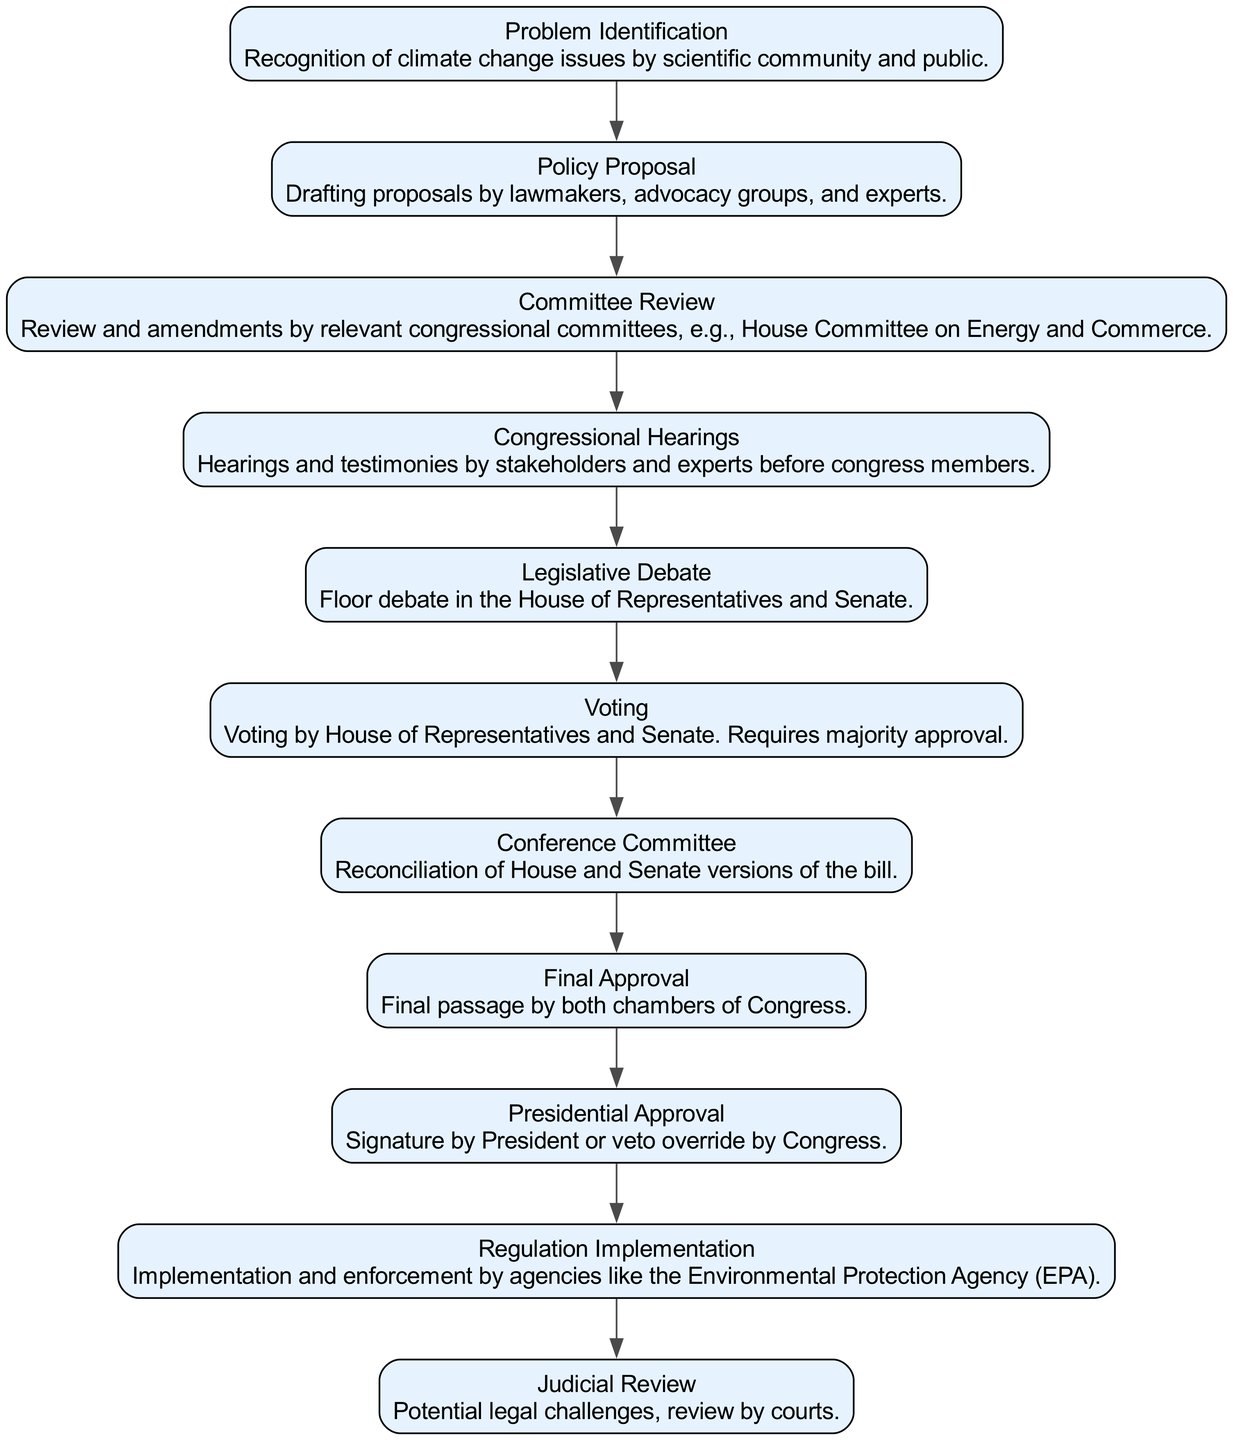What is the first step in the legislative process for enacting climate change regulations? The first step identified in the diagram is "Problem Identification," which is where the recognition of climate change issues occurs.
Answer: Problem Identification How many components are there in total? By counting the nodes in the diagram, there are 11 components listed.
Answer: 11 What happens after the "Policy Proposal"? The next step after "Policy Proposal" is "Committee Review," where the proposals are reviewed and amended by relevant congressional committees.
Answer: Committee Review Which component follows "Voting"? The component that follows "Voting" is "Conference Committee," which involves reconciling the House and Senate versions of the bill.
Answer: Conference Committee What role does the President play in the process? The President's role is encapsulated in the "Presidential Approval" step, where they either sign the bill or Congress may override a veto.
Answer: Presidential Approval How are legal challenges addressed in the process? Legal challenges are addressed during the "Judicial Review" phase, where potential challenges are reviewed by the courts.
Answer: Judicial Review What is the purpose of "Congressional Hearings"? The purpose of "Congressional Hearings" is to gather testimonies from stakeholders and experts before congress members.
Answer: Gather testimonies Describe the flow of the legislative process starting from "Legislative Debate" to "Regulation Implementation." After "Legislative Debate," the flow goes to "Voting" where the bill is voted upon. If approved, it moves to "Conference Committee" for reconciliation, then to "Final Approval" from both chambers. After that, it goes to the "Presidential Approval." Once approved, it leads to "Regulation Implementation," where enforcement is carried out by agencies like the EPA.
Answer: Voting, Conference Committee, Final Approval, Presidential Approval, Regulation Implementation In what component do the House of Representatives and Senate need majority approval? Majority approval is required in the "Voting" component from both the House of Representatives and Senate for the legislation.
Answer: Voting 